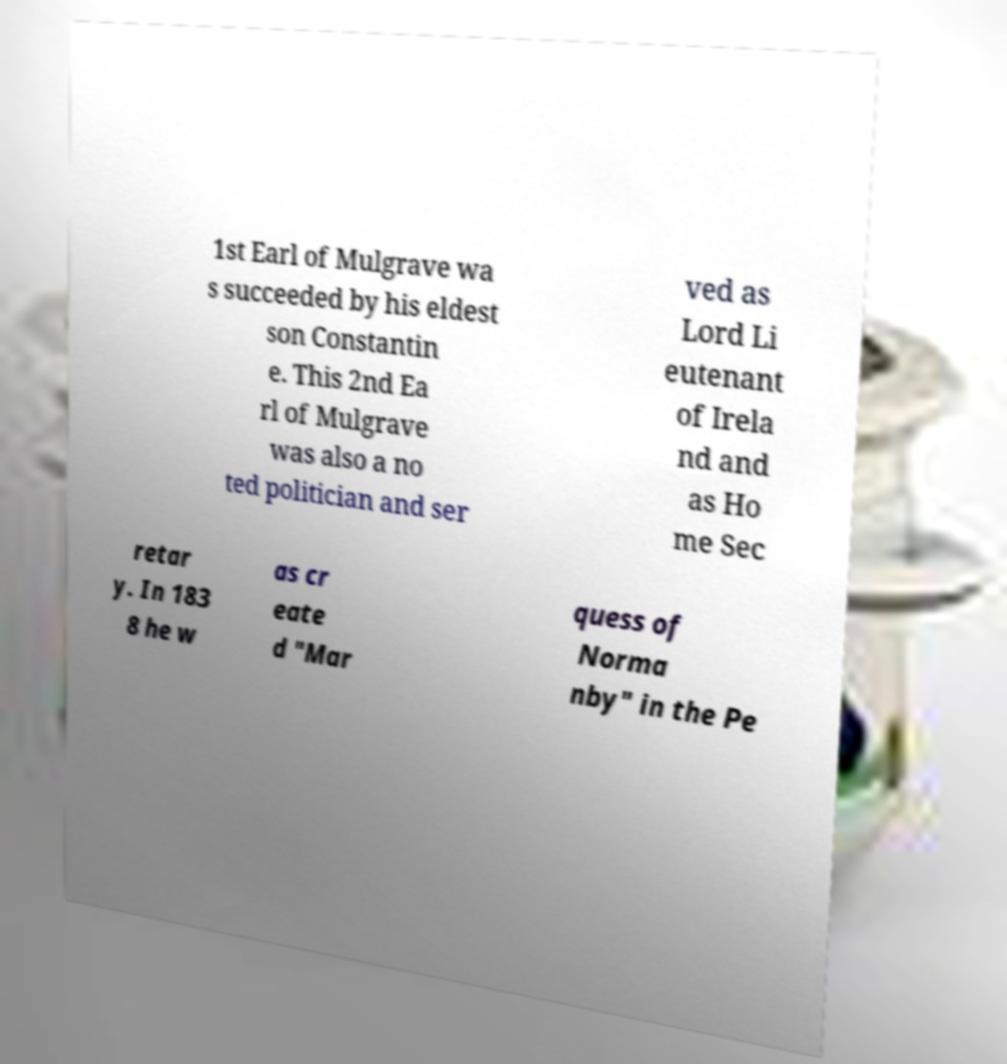Could you extract and type out the text from this image? 1st Earl of Mulgrave wa s succeeded by his eldest son Constantin e. This 2nd Ea rl of Mulgrave was also a no ted politician and ser ved as Lord Li eutenant of Irela nd and as Ho me Sec retar y. In 183 8 he w as cr eate d "Mar quess of Norma nby" in the Pe 